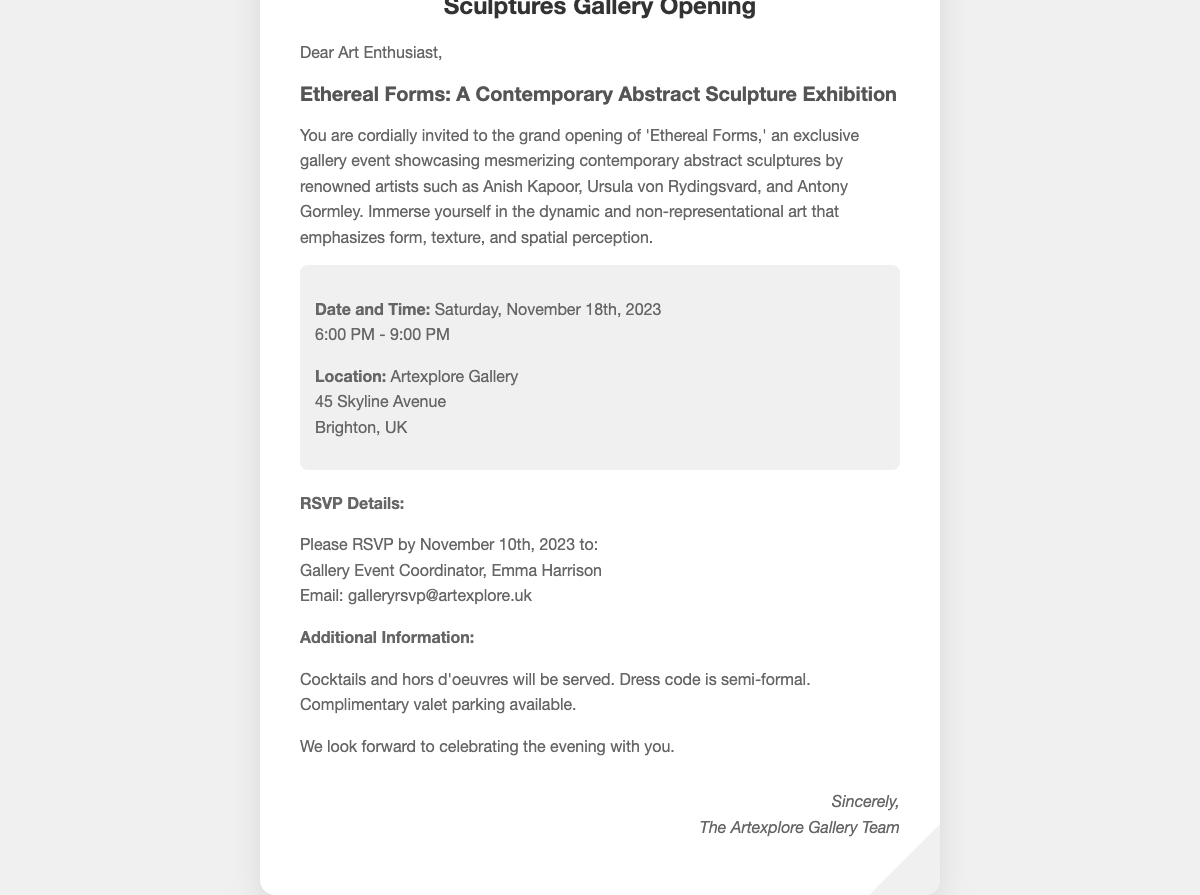What is the title of the exhibition? The title of the exhibition is presented prominently in the document.
Answer: Ethereal Forms Who is the gallery event coordinator? The document provides specific information about the person coordinating the event.
Answer: Emma Harrison What date is the gallery opening? The opening date is clearly stated in the document.
Answer: Saturday, November 18th, 2023 What time does the event start? The starting time for the event is mentioned in the details of the invitation.
Answer: 6:00 PM Where is the gallery located? The location of the gallery is included in the contact information section of the document.
Answer: Artexplore Gallery, 45 Skyline Avenue, Brighton, UK What is the RSVP deadline? The document states a specific date for when RSVPs should be sent.
Answer: November 10th, 2023 What type of refreshments will be served? The invitation mentions refreshments that will be available at the event.
Answer: Cocktails and hors d'oeuvres What is the dress code for the event? The dress code information is specified in the additional details section.
Answer: Semi-formal Is valet parking available? There is an explicit mention of parking options in the document.
Answer: Complimentary valet parking 